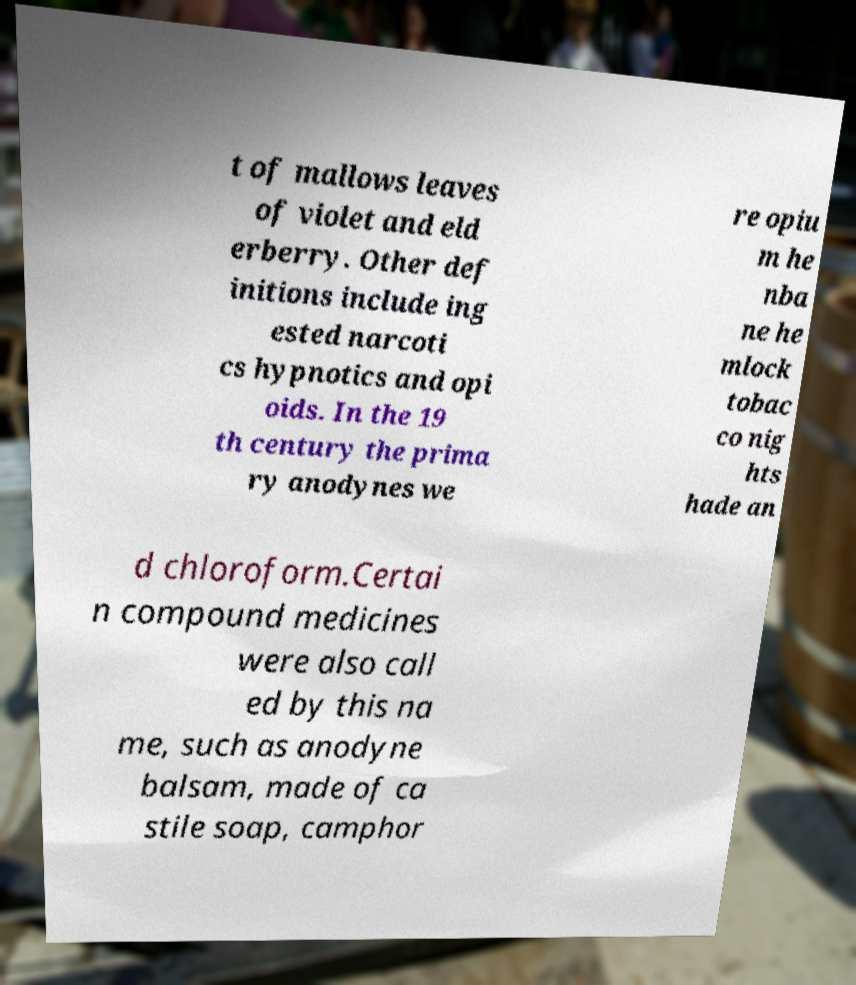What messages or text are displayed in this image? I need them in a readable, typed format. t of mallows leaves of violet and eld erberry. Other def initions include ing ested narcoti cs hypnotics and opi oids. In the 19 th century the prima ry anodynes we re opiu m he nba ne he mlock tobac co nig hts hade an d chloroform.Certai n compound medicines were also call ed by this na me, such as anodyne balsam, made of ca stile soap, camphor 